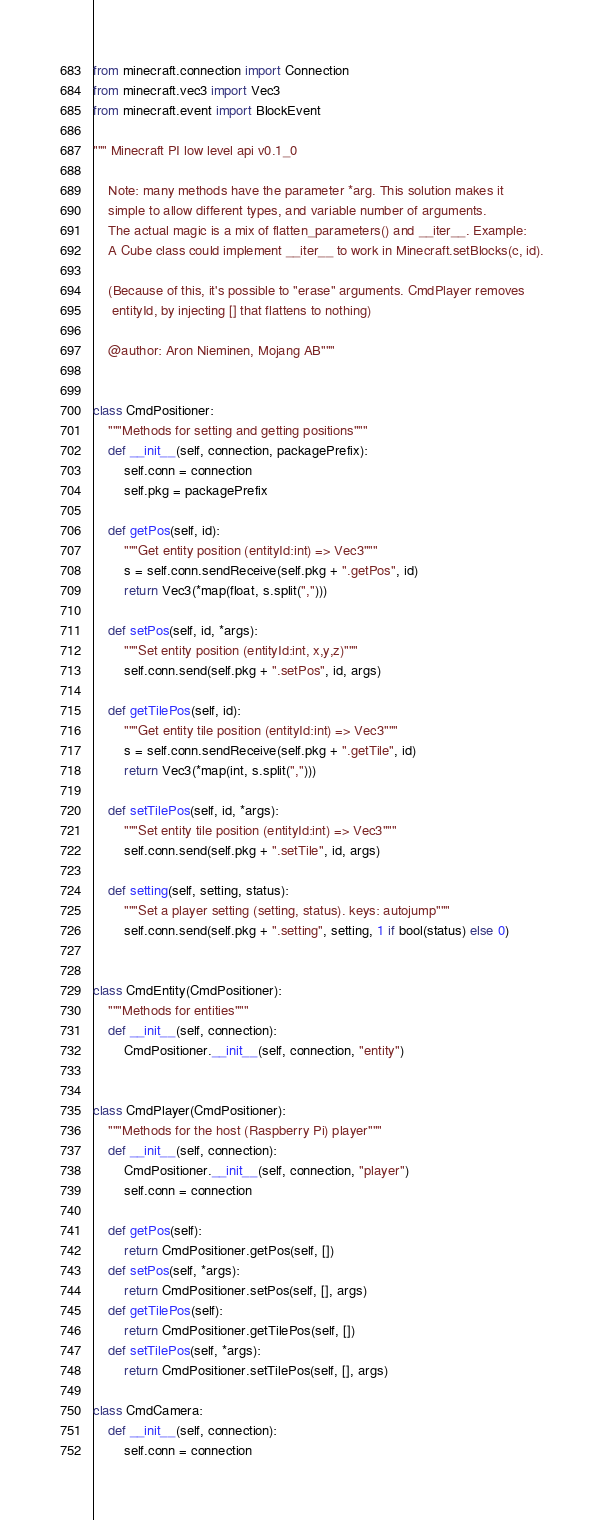Convert code to text. <code><loc_0><loc_0><loc_500><loc_500><_Python_>from minecraft.connection import Connection
from minecraft.vec3 import Vec3
from minecraft.event import BlockEvent

""" Minecraft PI low level api v0.1_0

    Note: many methods have the parameter *arg. This solution makes it
    simple to allow different types, and variable number of arguments.
    The actual magic is a mix of flatten_parameters() and __iter__. Example:
    A Cube class could implement __iter__ to work in Minecraft.setBlocks(c, id).

    (Because of this, it's possible to "erase" arguments. CmdPlayer removes
     entityId, by injecting [] that flattens to nothing)

    @author: Aron Nieminen, Mojang AB"""


class CmdPositioner:
    """Methods for setting and getting positions"""
    def __init__(self, connection, packagePrefix):
        self.conn = connection
        self.pkg = packagePrefix

    def getPos(self, id):
        """Get entity position (entityId:int) => Vec3"""
        s = self.conn.sendReceive(self.pkg + ".getPos", id)
        return Vec3(*map(float, s.split(",")))

    def setPos(self, id, *args):
        """Set entity position (entityId:int, x,y,z)"""
        self.conn.send(self.pkg + ".setPos", id, args)

    def getTilePos(self, id):
        """Get entity tile position (entityId:int) => Vec3"""
        s = self.conn.sendReceive(self.pkg + ".getTile", id)
        return Vec3(*map(int, s.split(",")))

    def setTilePos(self, id, *args):
        """Set entity tile position (entityId:int) => Vec3"""
        self.conn.send(self.pkg + ".setTile", id, args)

    def setting(self, setting, status):
        """Set a player setting (setting, status). keys: autojump"""
        self.conn.send(self.pkg + ".setting", setting, 1 if bool(status) else 0)


class CmdEntity(CmdPositioner):
    """Methods for entities"""
    def __init__(self, connection):
        CmdPositioner.__init__(self, connection, "entity")


class CmdPlayer(CmdPositioner):
    """Methods for the host (Raspberry Pi) player"""
    def __init__(self, connection):
        CmdPositioner.__init__(self, connection, "player")
        self.conn = connection

    def getPos(self):
        return CmdPositioner.getPos(self, [])
    def setPos(self, *args):
        return CmdPositioner.setPos(self, [], args)
    def getTilePos(self):
        return CmdPositioner.getTilePos(self, [])
    def setTilePos(self, *args):
        return CmdPositioner.setTilePos(self, [], args)

class CmdCamera:
    def __init__(self, connection):
        self.conn = connection
</code> 